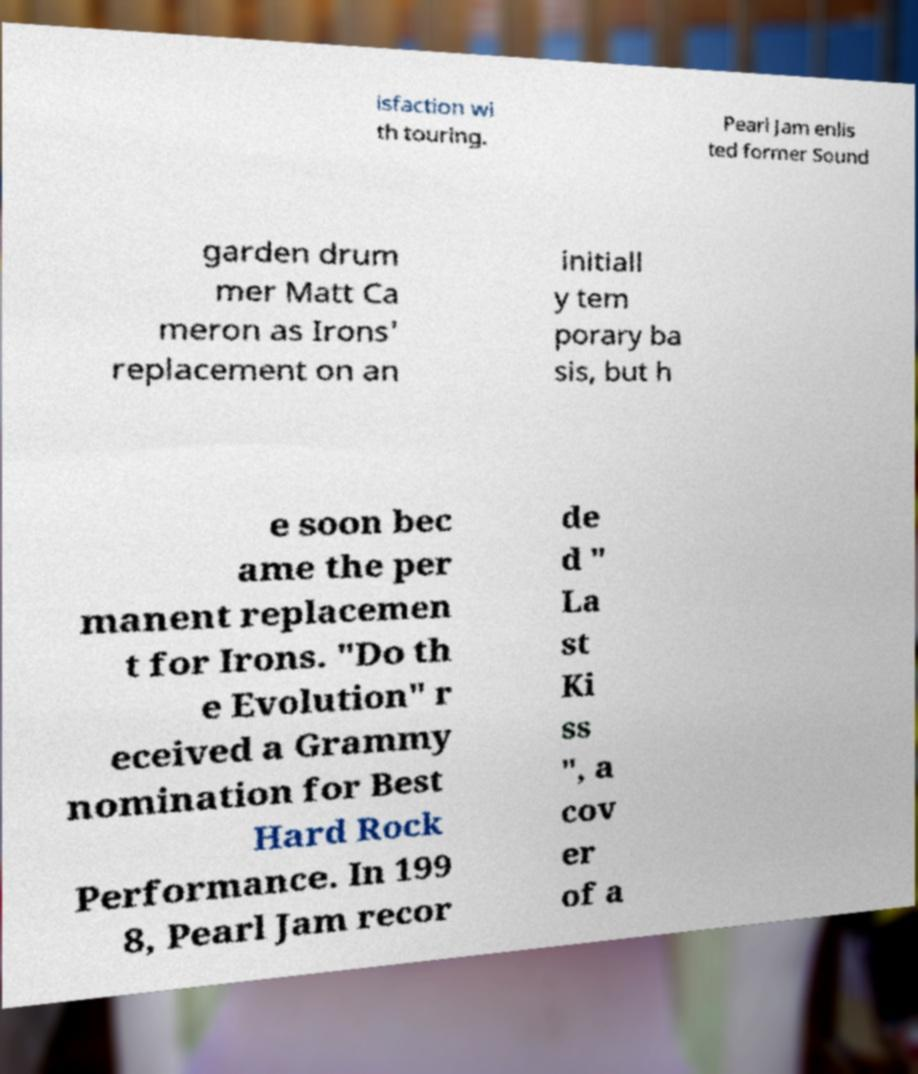There's text embedded in this image that I need extracted. Can you transcribe it verbatim? isfaction wi th touring. Pearl Jam enlis ted former Sound garden drum mer Matt Ca meron as Irons' replacement on an initiall y tem porary ba sis, but h e soon bec ame the per manent replacemen t for Irons. "Do th e Evolution" r eceived a Grammy nomination for Best Hard Rock Performance. In 199 8, Pearl Jam recor de d " La st Ki ss ", a cov er of a 